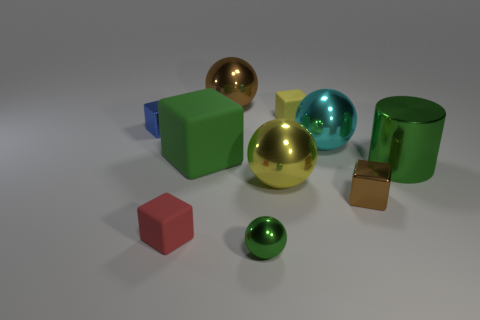Is there any other thing that has the same shape as the big green metallic thing?
Give a very brief answer. No. There is a tiny thing to the right of the cyan shiny sphere; what is it made of?
Give a very brief answer. Metal. There is a yellow metallic thing to the left of the tiny thing that is behind the small metal block that is left of the big brown shiny ball; what is its size?
Ensure brevity in your answer.  Large. There is a green matte object; is its size the same as the matte cube in front of the small brown metal thing?
Provide a short and direct response. No. There is a tiny metal thing that is to the left of the brown shiny sphere; what is its color?
Your answer should be very brief. Blue. What is the shape of the small metallic thing that is the same color as the big matte block?
Offer a very short reply. Sphere. What shape is the green metallic thing to the left of the yellow sphere?
Make the answer very short. Sphere. How many brown objects are either matte cubes or metallic cubes?
Keep it short and to the point. 1. Is the material of the small red thing the same as the large brown sphere?
Offer a very short reply. No. What number of small rubber objects are behind the green cylinder?
Offer a terse response. 1. 